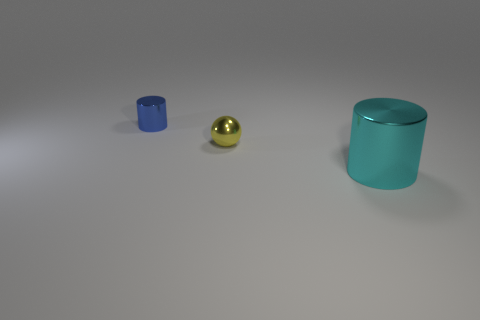Do the metallic ball and the metal cylinder that is in front of the tiny blue cylinder have the same size?
Your answer should be very brief. No. Are there more big cylinders behind the large cyan cylinder than large things?
Keep it short and to the point. No. There is a blue thing that is made of the same material as the sphere; what size is it?
Your answer should be very brief. Small. Is there another shiny thing of the same color as the big thing?
Make the answer very short. No. What number of things are either yellow metal spheres or tiny things that are on the right side of the blue shiny cylinder?
Make the answer very short. 1. Is the number of big gray spheres greater than the number of small yellow shiny spheres?
Provide a short and direct response. No. Are there any yellow things that have the same material as the blue object?
Make the answer very short. Yes. There is a thing that is both right of the small blue cylinder and behind the big cyan thing; what shape is it?
Provide a succinct answer. Sphere. How many other objects are there of the same shape as the tiny yellow object?
Provide a short and direct response. 0. What is the size of the yellow thing?
Your response must be concise. Small. 